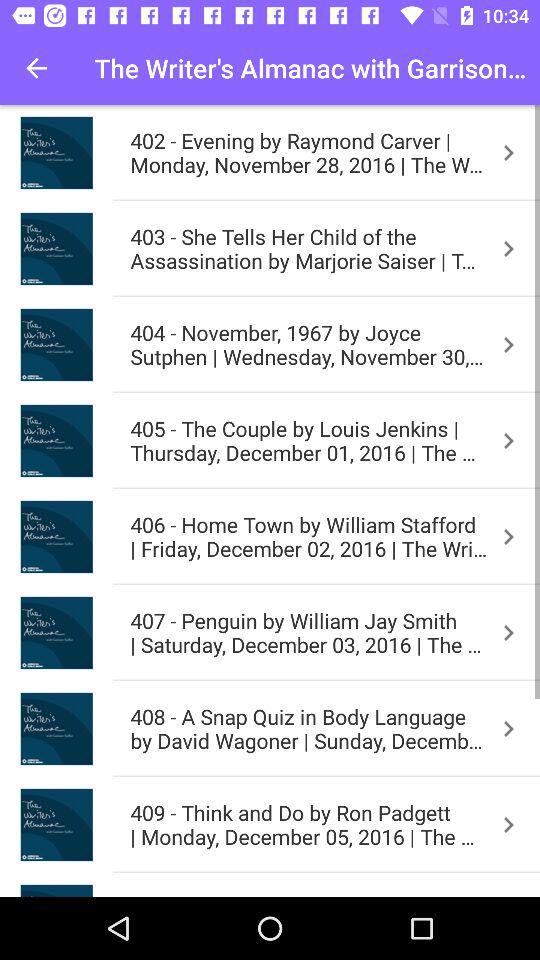What's described by the number 408? It's decribed "A Snap Quiz in Body Language by David Wagoner". 